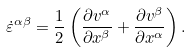Convert formula to latex. <formula><loc_0><loc_0><loc_500><loc_500>\dot { \varepsilon } ^ { \alpha \beta } = \frac { 1 } { 2 } \left ( \frac { \partial v ^ { \alpha } } { \partial x ^ { \beta } } + \frac { \partial v ^ { \beta } } { \partial x ^ { \alpha } } \right ) .</formula> 